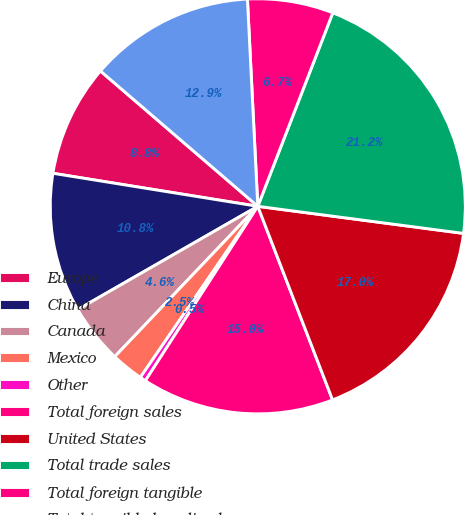<chart> <loc_0><loc_0><loc_500><loc_500><pie_chart><fcel>Europe<fcel>China<fcel>Canada<fcel>Mexico<fcel>Other<fcel>Total foreign sales<fcel>United States<fcel>Total trade sales<fcel>Total foreign tangible<fcel>Total tangible long-lived<nl><fcel>8.76%<fcel>10.83%<fcel>4.61%<fcel>2.53%<fcel>0.46%<fcel>14.98%<fcel>17.05%<fcel>21.2%<fcel>6.68%<fcel>12.9%<nl></chart> 